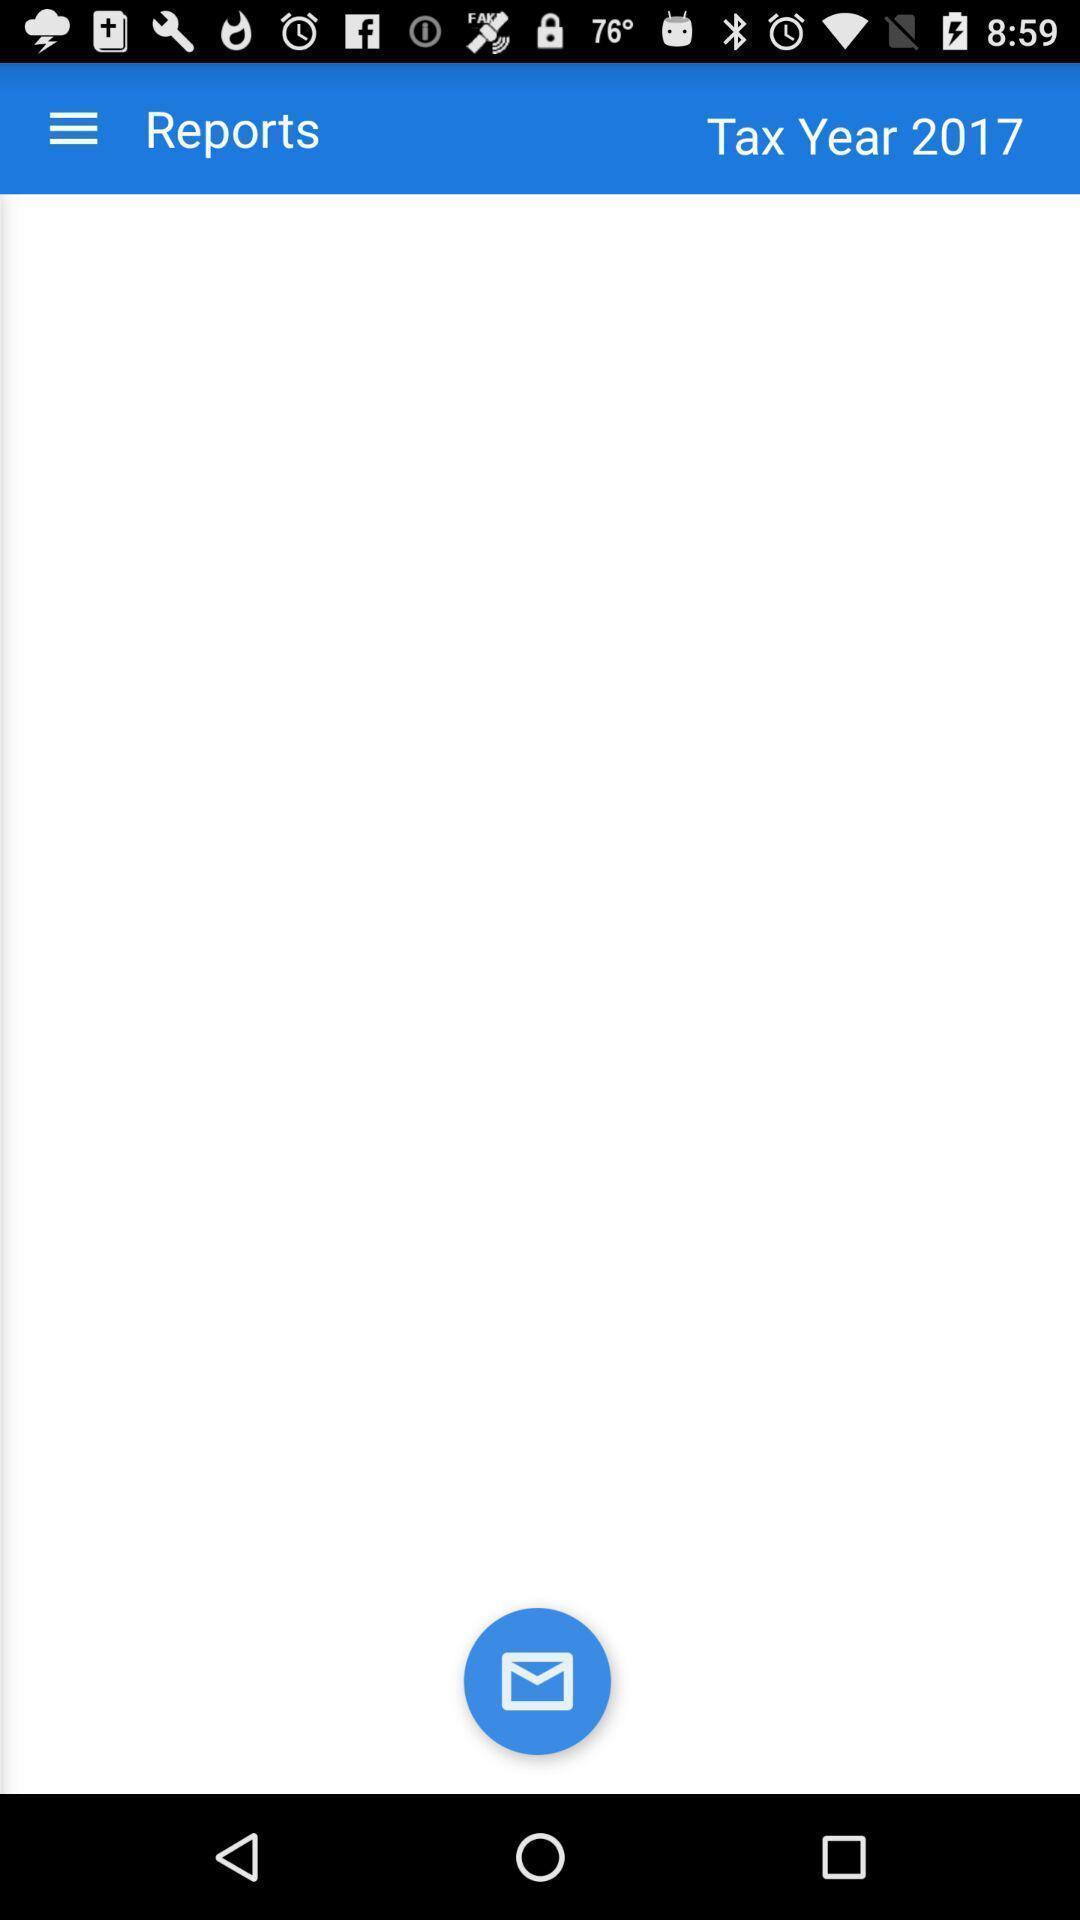Provide a description of this screenshot. Screen shows reports option. 